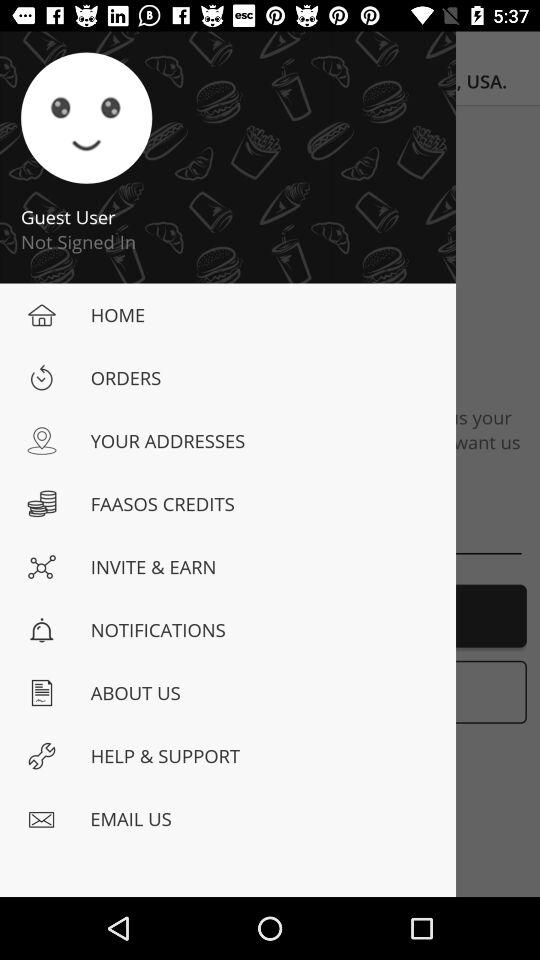Has the guest user signed in? The guest user has not signed in. 